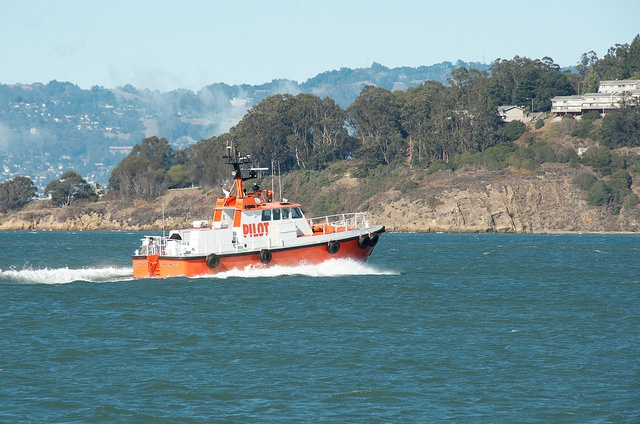Describe the objects in this image and their specific colors. I can see a boat in lightblue, white, gray, orange, and black tones in this image. 